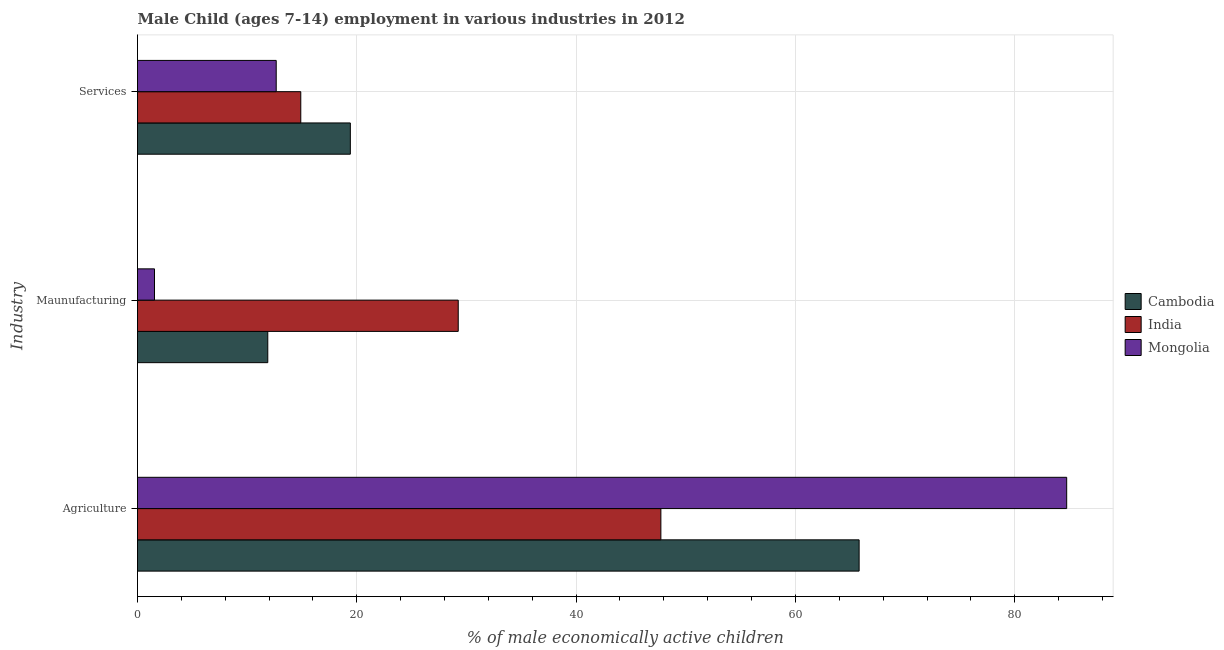How many groups of bars are there?
Provide a short and direct response. 3. Are the number of bars per tick equal to the number of legend labels?
Ensure brevity in your answer.  Yes. Are the number of bars on each tick of the Y-axis equal?
Make the answer very short. Yes. What is the label of the 1st group of bars from the top?
Your answer should be very brief. Services. What is the percentage of economically active children in agriculture in India?
Your response must be concise. 47.73. Across all countries, what is the maximum percentage of economically active children in agriculture?
Ensure brevity in your answer.  84.74. Across all countries, what is the minimum percentage of economically active children in manufacturing?
Make the answer very short. 1.55. In which country was the percentage of economically active children in manufacturing maximum?
Give a very brief answer. India. In which country was the percentage of economically active children in services minimum?
Provide a succinct answer. Mongolia. What is the total percentage of economically active children in agriculture in the graph?
Keep it short and to the point. 198.28. What is the difference between the percentage of economically active children in agriculture in Cambodia and that in Mongolia?
Provide a short and direct response. -18.93. What is the difference between the percentage of economically active children in agriculture in Cambodia and the percentage of economically active children in services in India?
Your answer should be compact. 50.92. What is the average percentage of economically active children in manufacturing per country?
Give a very brief answer. 14.23. What is the difference between the percentage of economically active children in agriculture and percentage of economically active children in services in India?
Your answer should be very brief. 32.84. In how many countries, is the percentage of economically active children in agriculture greater than 12 %?
Your answer should be very brief. 3. What is the ratio of the percentage of economically active children in services in India to that in Mongolia?
Ensure brevity in your answer.  1.18. Is the difference between the percentage of economically active children in agriculture in India and Cambodia greater than the difference between the percentage of economically active children in manufacturing in India and Cambodia?
Make the answer very short. No. What is the difference between the highest and the second highest percentage of economically active children in agriculture?
Provide a short and direct response. 18.93. What is the difference between the highest and the lowest percentage of economically active children in manufacturing?
Keep it short and to the point. 27.7. What does the 2nd bar from the top in Agriculture represents?
Give a very brief answer. India. What does the 3rd bar from the bottom in Maunufacturing represents?
Your answer should be compact. Mongolia. Is it the case that in every country, the sum of the percentage of economically active children in agriculture and percentage of economically active children in manufacturing is greater than the percentage of economically active children in services?
Give a very brief answer. Yes. How many countries are there in the graph?
Provide a succinct answer. 3. What is the difference between two consecutive major ticks on the X-axis?
Your response must be concise. 20. Does the graph contain any zero values?
Your response must be concise. No. Does the graph contain grids?
Offer a very short reply. Yes. Where does the legend appear in the graph?
Provide a succinct answer. Center right. How many legend labels are there?
Your response must be concise. 3. How are the legend labels stacked?
Provide a short and direct response. Vertical. What is the title of the graph?
Ensure brevity in your answer.  Male Child (ages 7-14) employment in various industries in 2012. Does "India" appear as one of the legend labels in the graph?
Provide a short and direct response. Yes. What is the label or title of the X-axis?
Your answer should be very brief. % of male economically active children. What is the label or title of the Y-axis?
Your response must be concise. Industry. What is the % of male economically active children in Cambodia in Agriculture?
Offer a very short reply. 65.81. What is the % of male economically active children in India in Agriculture?
Provide a succinct answer. 47.73. What is the % of male economically active children in Mongolia in Agriculture?
Provide a succinct answer. 84.74. What is the % of male economically active children in Cambodia in Maunufacturing?
Provide a succinct answer. 11.88. What is the % of male economically active children of India in Maunufacturing?
Provide a short and direct response. 29.25. What is the % of male economically active children in Mongolia in Maunufacturing?
Offer a terse response. 1.55. What is the % of male economically active children of Cambodia in Services?
Your response must be concise. 19.41. What is the % of male economically active children in India in Services?
Provide a short and direct response. 14.89. What is the % of male economically active children of Mongolia in Services?
Keep it short and to the point. 12.65. Across all Industry, what is the maximum % of male economically active children in Cambodia?
Your answer should be very brief. 65.81. Across all Industry, what is the maximum % of male economically active children in India?
Your answer should be very brief. 47.73. Across all Industry, what is the maximum % of male economically active children in Mongolia?
Keep it short and to the point. 84.74. Across all Industry, what is the minimum % of male economically active children of Cambodia?
Provide a short and direct response. 11.88. Across all Industry, what is the minimum % of male economically active children of India?
Ensure brevity in your answer.  14.89. Across all Industry, what is the minimum % of male economically active children of Mongolia?
Offer a very short reply. 1.55. What is the total % of male economically active children of Cambodia in the graph?
Make the answer very short. 97.1. What is the total % of male economically active children of India in the graph?
Ensure brevity in your answer.  91.87. What is the total % of male economically active children in Mongolia in the graph?
Ensure brevity in your answer.  98.94. What is the difference between the % of male economically active children in Cambodia in Agriculture and that in Maunufacturing?
Your answer should be very brief. 53.93. What is the difference between the % of male economically active children of India in Agriculture and that in Maunufacturing?
Offer a very short reply. 18.48. What is the difference between the % of male economically active children of Mongolia in Agriculture and that in Maunufacturing?
Make the answer very short. 83.19. What is the difference between the % of male economically active children in Cambodia in Agriculture and that in Services?
Offer a terse response. 46.4. What is the difference between the % of male economically active children in India in Agriculture and that in Services?
Ensure brevity in your answer.  32.84. What is the difference between the % of male economically active children of Mongolia in Agriculture and that in Services?
Provide a succinct answer. 72.09. What is the difference between the % of male economically active children in Cambodia in Maunufacturing and that in Services?
Provide a short and direct response. -7.53. What is the difference between the % of male economically active children in India in Maunufacturing and that in Services?
Make the answer very short. 14.36. What is the difference between the % of male economically active children in Cambodia in Agriculture and the % of male economically active children in India in Maunufacturing?
Your response must be concise. 36.56. What is the difference between the % of male economically active children of Cambodia in Agriculture and the % of male economically active children of Mongolia in Maunufacturing?
Keep it short and to the point. 64.26. What is the difference between the % of male economically active children of India in Agriculture and the % of male economically active children of Mongolia in Maunufacturing?
Keep it short and to the point. 46.18. What is the difference between the % of male economically active children in Cambodia in Agriculture and the % of male economically active children in India in Services?
Your response must be concise. 50.92. What is the difference between the % of male economically active children of Cambodia in Agriculture and the % of male economically active children of Mongolia in Services?
Your answer should be compact. 53.16. What is the difference between the % of male economically active children in India in Agriculture and the % of male economically active children in Mongolia in Services?
Your answer should be compact. 35.08. What is the difference between the % of male economically active children of Cambodia in Maunufacturing and the % of male economically active children of India in Services?
Provide a succinct answer. -3.01. What is the difference between the % of male economically active children in Cambodia in Maunufacturing and the % of male economically active children in Mongolia in Services?
Give a very brief answer. -0.77. What is the difference between the % of male economically active children of India in Maunufacturing and the % of male economically active children of Mongolia in Services?
Your answer should be very brief. 16.6. What is the average % of male economically active children of Cambodia per Industry?
Provide a succinct answer. 32.37. What is the average % of male economically active children of India per Industry?
Offer a very short reply. 30.62. What is the average % of male economically active children of Mongolia per Industry?
Your response must be concise. 32.98. What is the difference between the % of male economically active children of Cambodia and % of male economically active children of India in Agriculture?
Provide a short and direct response. 18.08. What is the difference between the % of male economically active children of Cambodia and % of male economically active children of Mongolia in Agriculture?
Offer a terse response. -18.93. What is the difference between the % of male economically active children in India and % of male economically active children in Mongolia in Agriculture?
Keep it short and to the point. -37.01. What is the difference between the % of male economically active children in Cambodia and % of male economically active children in India in Maunufacturing?
Provide a short and direct response. -17.37. What is the difference between the % of male economically active children in Cambodia and % of male economically active children in Mongolia in Maunufacturing?
Ensure brevity in your answer.  10.33. What is the difference between the % of male economically active children of India and % of male economically active children of Mongolia in Maunufacturing?
Keep it short and to the point. 27.7. What is the difference between the % of male economically active children in Cambodia and % of male economically active children in India in Services?
Your response must be concise. 4.52. What is the difference between the % of male economically active children in Cambodia and % of male economically active children in Mongolia in Services?
Make the answer very short. 6.76. What is the difference between the % of male economically active children in India and % of male economically active children in Mongolia in Services?
Ensure brevity in your answer.  2.24. What is the ratio of the % of male economically active children in Cambodia in Agriculture to that in Maunufacturing?
Offer a terse response. 5.54. What is the ratio of the % of male economically active children of India in Agriculture to that in Maunufacturing?
Offer a terse response. 1.63. What is the ratio of the % of male economically active children of Mongolia in Agriculture to that in Maunufacturing?
Offer a very short reply. 54.67. What is the ratio of the % of male economically active children in Cambodia in Agriculture to that in Services?
Keep it short and to the point. 3.39. What is the ratio of the % of male economically active children of India in Agriculture to that in Services?
Keep it short and to the point. 3.21. What is the ratio of the % of male economically active children of Mongolia in Agriculture to that in Services?
Your answer should be very brief. 6.7. What is the ratio of the % of male economically active children of Cambodia in Maunufacturing to that in Services?
Your response must be concise. 0.61. What is the ratio of the % of male economically active children of India in Maunufacturing to that in Services?
Your answer should be very brief. 1.96. What is the ratio of the % of male economically active children of Mongolia in Maunufacturing to that in Services?
Your answer should be compact. 0.12. What is the difference between the highest and the second highest % of male economically active children of Cambodia?
Keep it short and to the point. 46.4. What is the difference between the highest and the second highest % of male economically active children of India?
Offer a very short reply. 18.48. What is the difference between the highest and the second highest % of male economically active children in Mongolia?
Offer a terse response. 72.09. What is the difference between the highest and the lowest % of male economically active children in Cambodia?
Your answer should be very brief. 53.93. What is the difference between the highest and the lowest % of male economically active children of India?
Your response must be concise. 32.84. What is the difference between the highest and the lowest % of male economically active children of Mongolia?
Offer a terse response. 83.19. 